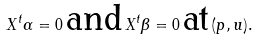Convert formula to latex. <formula><loc_0><loc_0><loc_500><loc_500>X ^ { t } \alpha = 0 \, \text {and} \, X ^ { t } \beta = 0 \, \text {at} \, ( p , u ) .</formula> 